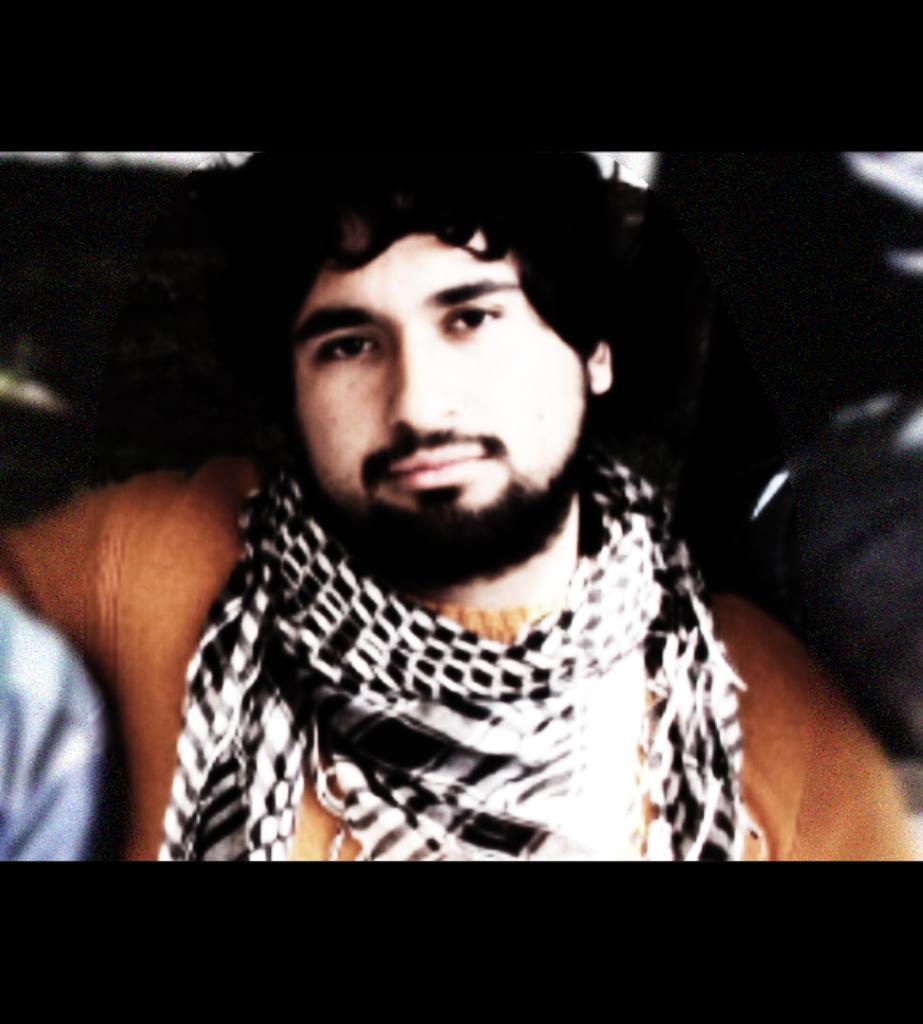Describe this image in one or two sentences. In the image there is a man in brown t-shirt and black scarf and the background is dark. 